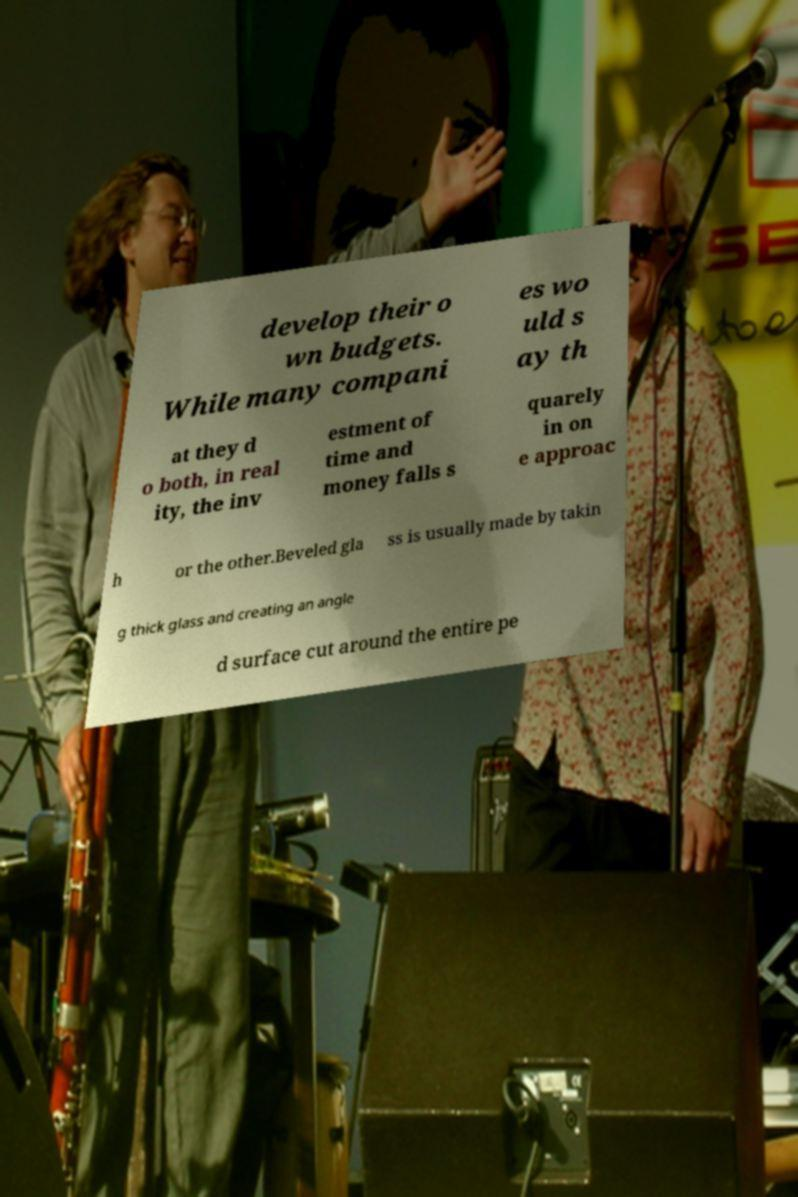Can you read and provide the text displayed in the image?This photo seems to have some interesting text. Can you extract and type it out for me? develop their o wn budgets. While many compani es wo uld s ay th at they d o both, in real ity, the inv estment of time and money falls s quarely in on e approac h or the other.Beveled gla ss is usually made by takin g thick glass and creating an angle d surface cut around the entire pe 